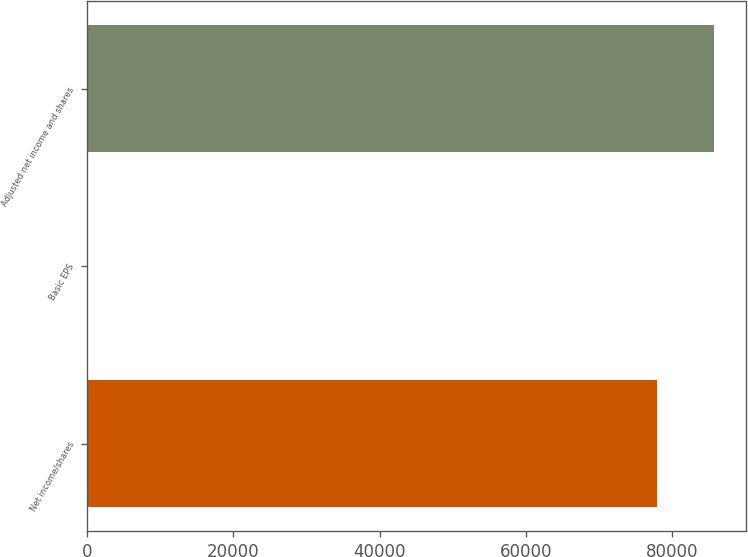<chart> <loc_0><loc_0><loc_500><loc_500><bar_chart><fcel>Net income/shares<fcel>Basic EPS<fcel>Adjusted net income and shares<nl><fcel>77992<fcel>1.37<fcel>85791.1<nl></chart> 